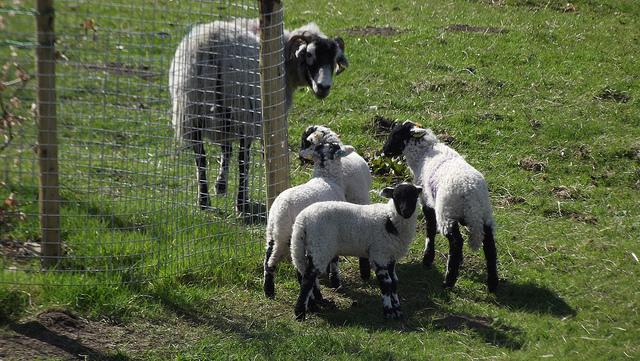How many babies are there?
Concise answer only. 3. What kind of animals are these?
Be succinct. Sheep. Is this daytime?
Short answer required. Yes. 